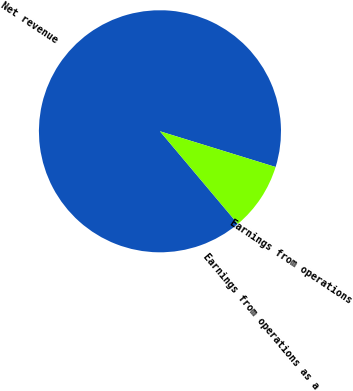Convert chart. <chart><loc_0><loc_0><loc_500><loc_500><pie_chart><fcel>Net revenue<fcel>Earnings from operations<fcel>Earnings from operations as a<nl><fcel>90.89%<fcel>9.1%<fcel>0.01%<nl></chart> 